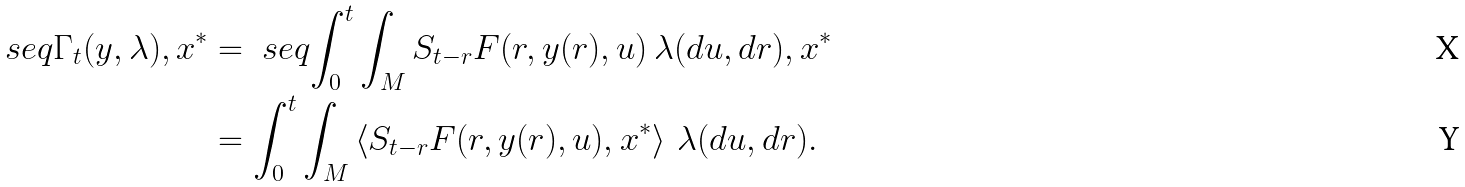<formula> <loc_0><loc_0><loc_500><loc_500>\ s e q { \Gamma _ { t } ( y , \lambda ) , x ^ { * } } & = \ s e q { \int _ { 0 } ^ { t } \int _ { M } S _ { t - r } F ( r , y ( r ) , u ) \, \lambda ( d u , d r ) , x ^ { * } } \\ & = \int _ { 0 } ^ { t } \int _ { M } \left \langle S _ { t - r } F ( r , y ( r ) , u ) , x ^ { * } \right \rangle \, \lambda ( d u , d r ) .</formula> 